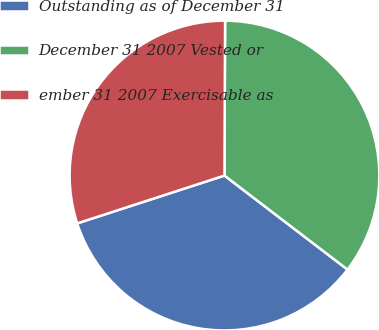Convert chart to OTSL. <chart><loc_0><loc_0><loc_500><loc_500><pie_chart><fcel>Outstanding as of December 31<fcel>December 31 2007 Vested or<fcel>ember 31 2007 Exercisable as<nl><fcel>34.62%<fcel>35.32%<fcel>30.06%<nl></chart> 